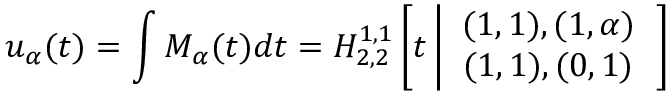Convert formula to latex. <formula><loc_0><loc_0><loc_500><loc_500>u _ { \alpha } ( t ) = \int M _ { \alpha } ( t ) d t = H _ { 2 , 2 } ^ { 1 , 1 } \left [ t \left | \begin{array} { c } { ( 1 , 1 ) , ( 1 , \alpha ) } \\ { ( 1 , 1 ) , ( 0 , 1 ) } \end{array} \right ]</formula> 